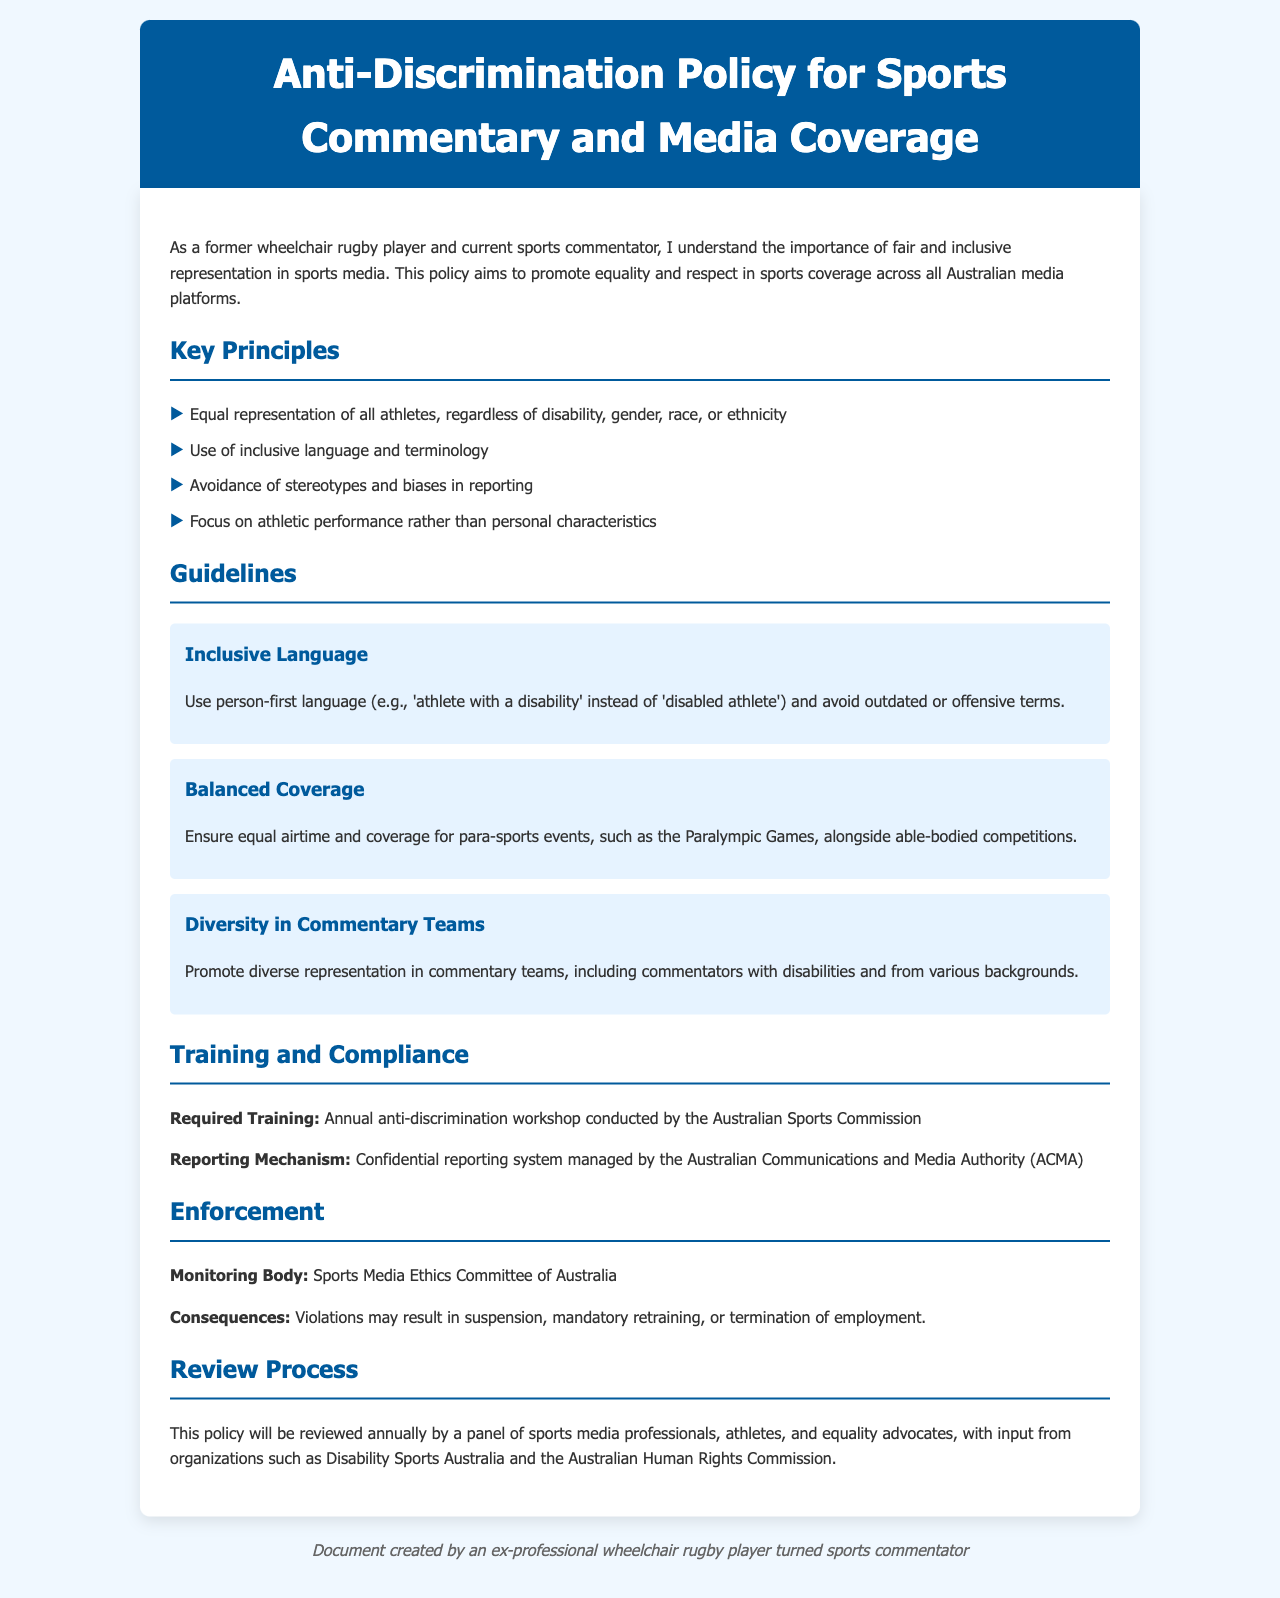What is the title of the document? The title of the document is indicated in the header section.
Answer: Anti-Discrimination Policy for Sports Commentary and Media Coverage How often will the policy be reviewed? The policy states that it will be reviewed annually.
Answer: Annually Who conducts the required training? The document mentions the organization responsible for conducting the anti-discrimination workshop.
Answer: Australian Sports Commission What does the monitoring body focus on? The document specifies the purpose of the Sports Media Ethics Committee of Australia.
Answer: Monitoring What should be avoided in language use? The guidelines specify what type of language should be avoided in reporting.
Answer: Outdated or offensive terms What is one principle emphasized in the document? The document lists key principles that guide sports commentary and media coverage.
Answer: Equal representation of all athletes Where is the reporting mechanism managed? The document identifies the organization responsible for the confidential reporting system.
Answer: Australian Communications and Media Authority (ACMA) What type of coverage is encouraged? The guideline addresses the balance that should be present in coverage of sports events.
Answer: Equal airtime and coverage for para-sports events 